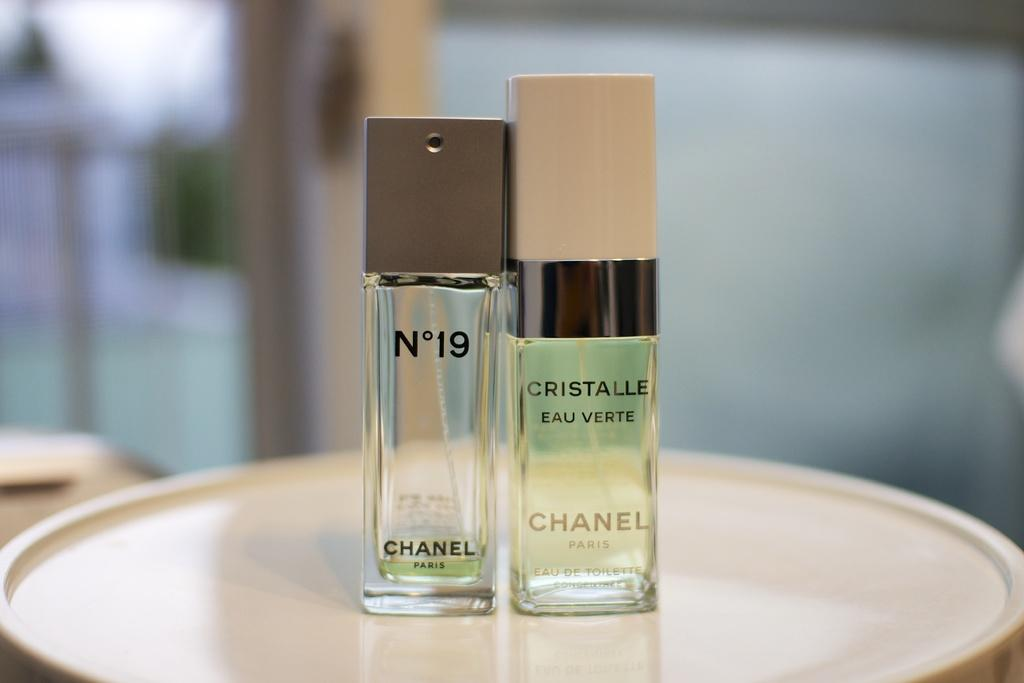Provide a one-sentence caption for the provided image. Two beauty products made by Chanel stand side by side. 